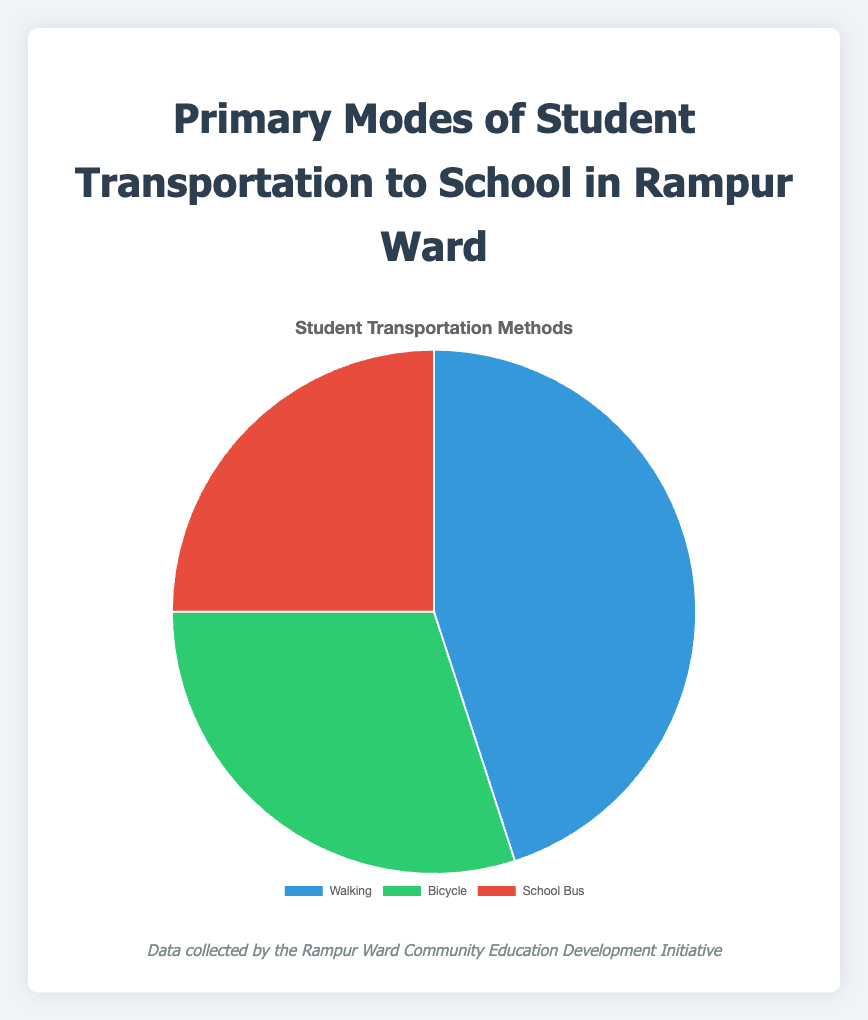What percentage of students use a Bicycle or a School Bus combined? To find this, add the percentage of students who use a Bicycle (30%) and the percentage who use a School Bus (25%). 30% + 25% = 55%
Answer: 55% Which mode of transport has the highest percentage of use? The highest percentage of use can be identified by comparing the given values: Walking (45%), Bicycle (30%), and School Bus (25%). Walking has the highest value.
Answer: Walking How much greater is the percentage of students walking to school compared to those using a school bus? Subtract the percentage of students using a school bus (25%) from the percentage of students walking (45%). 45% - 25% = 20%
Answer: 20% What is the total percentage of students using either Walking or Bicycle modes? Add the percentage of students walking (45%) and those using a bicycle (30%). 45% + 30% = 75%
Answer: 75% Which mode of transport has the smallest usage percentage? Compare the percentages given for each mode of transport: Walking (45%), Bicycle (30%), and School Bus (25%). The smallest percentage is for the School Bus.
Answer: School Bus What color represents students who use a bicycle in the pie chart? According to the color coding provided in the description, students who use a bicycle are represented by the green color.
Answer: Green If the percentage of students using the School Bus doubled, what would it be, and how would that impact the overall distribution? Doubling the percentage of students using a School Bus: 25% * 2 = 50%. Since the total percentage must remain 100%, the percentages of others would need to adjust downwards.
Answer: 50%, others decrease What is the difference between the percentages of students using the Bicycle and those using the School Bus? Subtract the percentage of students using the School Bus (25%) from the percentage of those using the Bicycle (30%). 30% - 25% = 5%
Answer: 5% Which segment(s) of the pie chart would you adjust if more students started using school buses and fewer used bicycles? If school bus usage increased, the % for bicycles would need to decrease to keep the total at 100%. This would make the Bicycle segment shrink and the School Bus segment grow.
Answer: Bicycle smaller, School Bus larger 